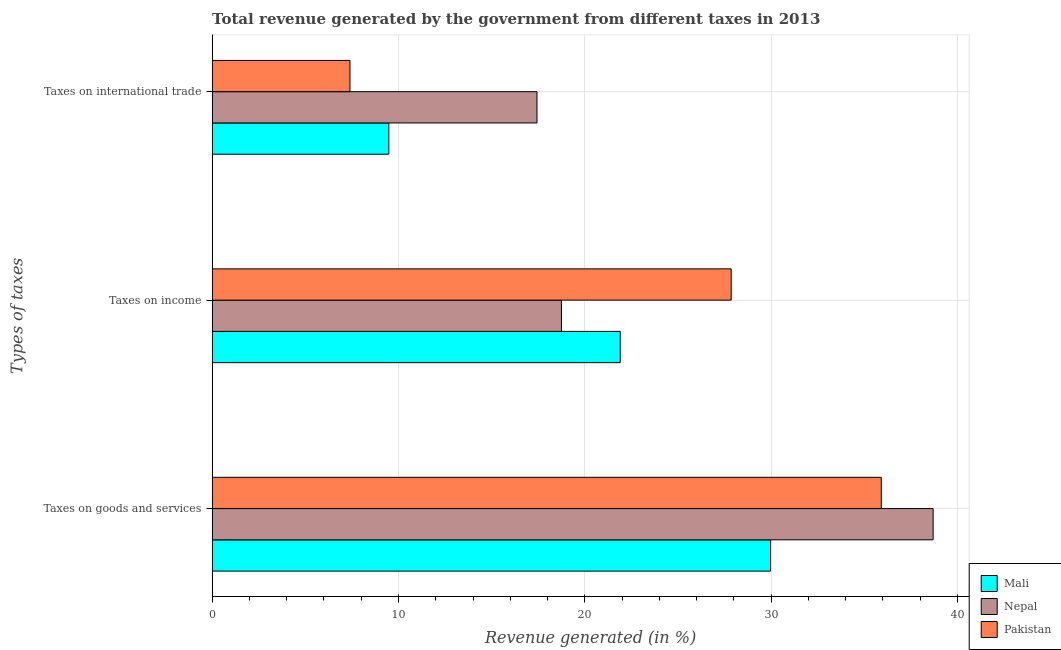How many different coloured bars are there?
Your response must be concise. 3. Are the number of bars per tick equal to the number of legend labels?
Keep it short and to the point. Yes. Are the number of bars on each tick of the Y-axis equal?
Offer a terse response. Yes. What is the label of the 2nd group of bars from the top?
Keep it short and to the point. Taxes on income. What is the percentage of revenue generated by tax on international trade in Nepal?
Provide a succinct answer. 17.43. Across all countries, what is the maximum percentage of revenue generated by taxes on income?
Ensure brevity in your answer.  27.85. Across all countries, what is the minimum percentage of revenue generated by taxes on income?
Your answer should be very brief. 18.74. In which country was the percentage of revenue generated by tax on international trade maximum?
Provide a short and direct response. Nepal. In which country was the percentage of revenue generated by taxes on income minimum?
Give a very brief answer. Nepal. What is the total percentage of revenue generated by taxes on goods and services in the graph?
Provide a succinct answer. 104.57. What is the difference between the percentage of revenue generated by taxes on goods and services in Mali and that in Nepal?
Offer a very short reply. -8.73. What is the difference between the percentage of revenue generated by taxes on goods and services in Nepal and the percentage of revenue generated by taxes on income in Pakistan?
Offer a very short reply. 10.84. What is the average percentage of revenue generated by taxes on goods and services per country?
Offer a very short reply. 34.86. What is the difference between the percentage of revenue generated by taxes on goods and services and percentage of revenue generated by tax on international trade in Pakistan?
Give a very brief answer. 28.51. In how many countries, is the percentage of revenue generated by taxes on income greater than 22 %?
Provide a succinct answer. 1. What is the ratio of the percentage of revenue generated by taxes on income in Nepal to that in Mali?
Your answer should be compact. 0.86. Is the percentage of revenue generated by tax on international trade in Nepal less than that in Pakistan?
Keep it short and to the point. No. Is the difference between the percentage of revenue generated by taxes on goods and services in Nepal and Pakistan greater than the difference between the percentage of revenue generated by tax on international trade in Nepal and Pakistan?
Ensure brevity in your answer.  No. What is the difference between the highest and the second highest percentage of revenue generated by tax on international trade?
Your answer should be compact. 7.95. What is the difference between the highest and the lowest percentage of revenue generated by tax on international trade?
Ensure brevity in your answer.  10.04. In how many countries, is the percentage of revenue generated by taxes on income greater than the average percentage of revenue generated by taxes on income taken over all countries?
Keep it short and to the point. 1. What does the 2nd bar from the bottom in Taxes on international trade represents?
Offer a very short reply. Nepal. Is it the case that in every country, the sum of the percentage of revenue generated by taxes on goods and services and percentage of revenue generated by taxes on income is greater than the percentage of revenue generated by tax on international trade?
Provide a succinct answer. Yes. How many bars are there?
Offer a terse response. 9. Are all the bars in the graph horizontal?
Offer a very short reply. Yes. What is the difference between two consecutive major ticks on the X-axis?
Your response must be concise. 10. Are the values on the major ticks of X-axis written in scientific E-notation?
Offer a very short reply. No. Does the graph contain any zero values?
Give a very brief answer. No. Where does the legend appear in the graph?
Provide a succinct answer. Bottom right. How are the legend labels stacked?
Offer a terse response. Vertical. What is the title of the graph?
Ensure brevity in your answer.  Total revenue generated by the government from different taxes in 2013. Does "Oman" appear as one of the legend labels in the graph?
Ensure brevity in your answer.  No. What is the label or title of the X-axis?
Make the answer very short. Revenue generated (in %). What is the label or title of the Y-axis?
Provide a succinct answer. Types of taxes. What is the Revenue generated (in %) of Mali in Taxes on goods and services?
Keep it short and to the point. 29.97. What is the Revenue generated (in %) in Nepal in Taxes on goods and services?
Offer a very short reply. 38.69. What is the Revenue generated (in %) in Pakistan in Taxes on goods and services?
Give a very brief answer. 35.91. What is the Revenue generated (in %) of Mali in Taxes on income?
Give a very brief answer. 21.9. What is the Revenue generated (in %) in Nepal in Taxes on income?
Keep it short and to the point. 18.74. What is the Revenue generated (in %) of Pakistan in Taxes on income?
Keep it short and to the point. 27.85. What is the Revenue generated (in %) of Mali in Taxes on international trade?
Offer a very short reply. 9.48. What is the Revenue generated (in %) of Nepal in Taxes on international trade?
Offer a very short reply. 17.43. What is the Revenue generated (in %) of Pakistan in Taxes on international trade?
Your response must be concise. 7.4. Across all Types of taxes, what is the maximum Revenue generated (in %) in Mali?
Provide a short and direct response. 29.97. Across all Types of taxes, what is the maximum Revenue generated (in %) of Nepal?
Make the answer very short. 38.69. Across all Types of taxes, what is the maximum Revenue generated (in %) in Pakistan?
Provide a succinct answer. 35.91. Across all Types of taxes, what is the minimum Revenue generated (in %) in Mali?
Your response must be concise. 9.48. Across all Types of taxes, what is the minimum Revenue generated (in %) in Nepal?
Make the answer very short. 17.43. Across all Types of taxes, what is the minimum Revenue generated (in %) in Pakistan?
Your answer should be compact. 7.4. What is the total Revenue generated (in %) of Mali in the graph?
Provide a short and direct response. 61.35. What is the total Revenue generated (in %) in Nepal in the graph?
Offer a very short reply. 74.87. What is the total Revenue generated (in %) of Pakistan in the graph?
Provide a succinct answer. 71.16. What is the difference between the Revenue generated (in %) of Mali in Taxes on goods and services and that in Taxes on income?
Make the answer very short. 8.06. What is the difference between the Revenue generated (in %) of Nepal in Taxes on goods and services and that in Taxes on income?
Offer a very short reply. 19.95. What is the difference between the Revenue generated (in %) of Pakistan in Taxes on goods and services and that in Taxes on income?
Your response must be concise. 8.05. What is the difference between the Revenue generated (in %) in Mali in Taxes on goods and services and that in Taxes on international trade?
Offer a terse response. 20.48. What is the difference between the Revenue generated (in %) in Nepal in Taxes on goods and services and that in Taxes on international trade?
Provide a short and direct response. 21.26. What is the difference between the Revenue generated (in %) in Pakistan in Taxes on goods and services and that in Taxes on international trade?
Your answer should be compact. 28.51. What is the difference between the Revenue generated (in %) in Mali in Taxes on income and that in Taxes on international trade?
Provide a succinct answer. 12.42. What is the difference between the Revenue generated (in %) of Nepal in Taxes on income and that in Taxes on international trade?
Your response must be concise. 1.31. What is the difference between the Revenue generated (in %) of Pakistan in Taxes on income and that in Taxes on international trade?
Your answer should be very brief. 20.46. What is the difference between the Revenue generated (in %) in Mali in Taxes on goods and services and the Revenue generated (in %) in Nepal in Taxes on income?
Provide a succinct answer. 11.22. What is the difference between the Revenue generated (in %) of Mali in Taxes on goods and services and the Revenue generated (in %) of Pakistan in Taxes on income?
Keep it short and to the point. 2.11. What is the difference between the Revenue generated (in %) of Nepal in Taxes on goods and services and the Revenue generated (in %) of Pakistan in Taxes on income?
Your answer should be compact. 10.84. What is the difference between the Revenue generated (in %) in Mali in Taxes on goods and services and the Revenue generated (in %) in Nepal in Taxes on international trade?
Provide a succinct answer. 12.53. What is the difference between the Revenue generated (in %) of Mali in Taxes on goods and services and the Revenue generated (in %) of Pakistan in Taxes on international trade?
Ensure brevity in your answer.  22.57. What is the difference between the Revenue generated (in %) of Nepal in Taxes on goods and services and the Revenue generated (in %) of Pakistan in Taxes on international trade?
Ensure brevity in your answer.  31.3. What is the difference between the Revenue generated (in %) of Mali in Taxes on income and the Revenue generated (in %) of Nepal in Taxes on international trade?
Give a very brief answer. 4.47. What is the difference between the Revenue generated (in %) of Mali in Taxes on income and the Revenue generated (in %) of Pakistan in Taxes on international trade?
Your answer should be very brief. 14.51. What is the difference between the Revenue generated (in %) of Nepal in Taxes on income and the Revenue generated (in %) of Pakistan in Taxes on international trade?
Your answer should be compact. 11.35. What is the average Revenue generated (in %) in Mali per Types of taxes?
Give a very brief answer. 20.45. What is the average Revenue generated (in %) in Nepal per Types of taxes?
Provide a short and direct response. 24.96. What is the average Revenue generated (in %) in Pakistan per Types of taxes?
Give a very brief answer. 23.72. What is the difference between the Revenue generated (in %) in Mali and Revenue generated (in %) in Nepal in Taxes on goods and services?
Provide a short and direct response. -8.73. What is the difference between the Revenue generated (in %) of Mali and Revenue generated (in %) of Pakistan in Taxes on goods and services?
Provide a short and direct response. -5.94. What is the difference between the Revenue generated (in %) in Nepal and Revenue generated (in %) in Pakistan in Taxes on goods and services?
Your answer should be compact. 2.78. What is the difference between the Revenue generated (in %) in Mali and Revenue generated (in %) in Nepal in Taxes on income?
Your answer should be compact. 3.16. What is the difference between the Revenue generated (in %) in Mali and Revenue generated (in %) in Pakistan in Taxes on income?
Your answer should be very brief. -5.95. What is the difference between the Revenue generated (in %) in Nepal and Revenue generated (in %) in Pakistan in Taxes on income?
Make the answer very short. -9.11. What is the difference between the Revenue generated (in %) of Mali and Revenue generated (in %) of Nepal in Taxes on international trade?
Offer a very short reply. -7.95. What is the difference between the Revenue generated (in %) in Mali and Revenue generated (in %) in Pakistan in Taxes on international trade?
Offer a very short reply. 2.09. What is the difference between the Revenue generated (in %) in Nepal and Revenue generated (in %) in Pakistan in Taxes on international trade?
Ensure brevity in your answer.  10.04. What is the ratio of the Revenue generated (in %) of Mali in Taxes on goods and services to that in Taxes on income?
Offer a terse response. 1.37. What is the ratio of the Revenue generated (in %) in Nepal in Taxes on goods and services to that in Taxes on income?
Your answer should be very brief. 2.06. What is the ratio of the Revenue generated (in %) of Pakistan in Taxes on goods and services to that in Taxes on income?
Provide a succinct answer. 1.29. What is the ratio of the Revenue generated (in %) of Mali in Taxes on goods and services to that in Taxes on international trade?
Provide a short and direct response. 3.16. What is the ratio of the Revenue generated (in %) in Nepal in Taxes on goods and services to that in Taxes on international trade?
Your answer should be very brief. 2.22. What is the ratio of the Revenue generated (in %) in Pakistan in Taxes on goods and services to that in Taxes on international trade?
Your answer should be very brief. 4.85. What is the ratio of the Revenue generated (in %) in Mali in Taxes on income to that in Taxes on international trade?
Your response must be concise. 2.31. What is the ratio of the Revenue generated (in %) of Nepal in Taxes on income to that in Taxes on international trade?
Give a very brief answer. 1.08. What is the ratio of the Revenue generated (in %) of Pakistan in Taxes on income to that in Taxes on international trade?
Make the answer very short. 3.77. What is the difference between the highest and the second highest Revenue generated (in %) in Mali?
Provide a short and direct response. 8.06. What is the difference between the highest and the second highest Revenue generated (in %) of Nepal?
Keep it short and to the point. 19.95. What is the difference between the highest and the second highest Revenue generated (in %) in Pakistan?
Offer a terse response. 8.05. What is the difference between the highest and the lowest Revenue generated (in %) in Mali?
Give a very brief answer. 20.48. What is the difference between the highest and the lowest Revenue generated (in %) in Nepal?
Give a very brief answer. 21.26. What is the difference between the highest and the lowest Revenue generated (in %) in Pakistan?
Ensure brevity in your answer.  28.51. 